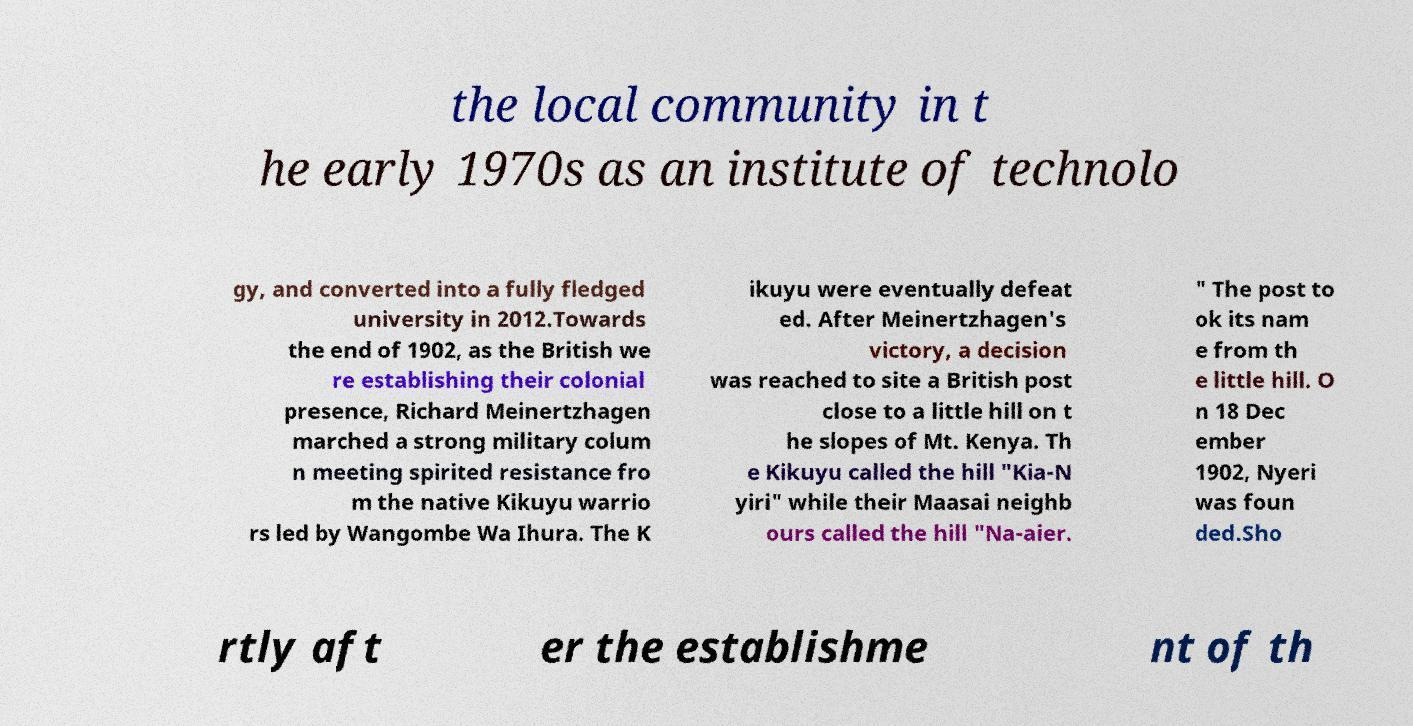Can you accurately transcribe the text from the provided image for me? the local community in t he early 1970s as an institute of technolo gy, and converted into a fully fledged university in 2012.Towards the end of 1902, as the British we re establishing their colonial presence, Richard Meinertzhagen marched a strong military colum n meeting spirited resistance fro m the native Kikuyu warrio rs led by Wangombe Wa Ihura. The K ikuyu were eventually defeat ed. After Meinertzhagen's victory, a decision was reached to site a British post close to a little hill on t he slopes of Mt. Kenya. Th e Kikuyu called the hill "Kia-N yiri" while their Maasai neighb ours called the hill "Na-aier. " The post to ok its nam e from th e little hill. O n 18 Dec ember 1902, Nyeri was foun ded.Sho rtly aft er the establishme nt of th 